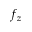Convert formula to latex. <formula><loc_0><loc_0><loc_500><loc_500>f _ { z }</formula> 